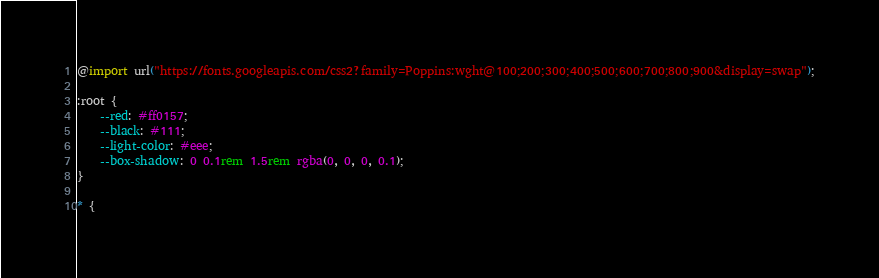Convert code to text. <code><loc_0><loc_0><loc_500><loc_500><_CSS_>@import url("https://fonts.googleapis.com/css2?family=Poppins:wght@100;200;300;400;500;600;700;800;900&display=swap");

:root {
    --red: #ff0157;
    --black: #111;
    --light-color: #eee;
    --box-shadow: 0 0.1rem 1.5rem rgba(0, 0, 0, 0.1);
}

* {</code> 